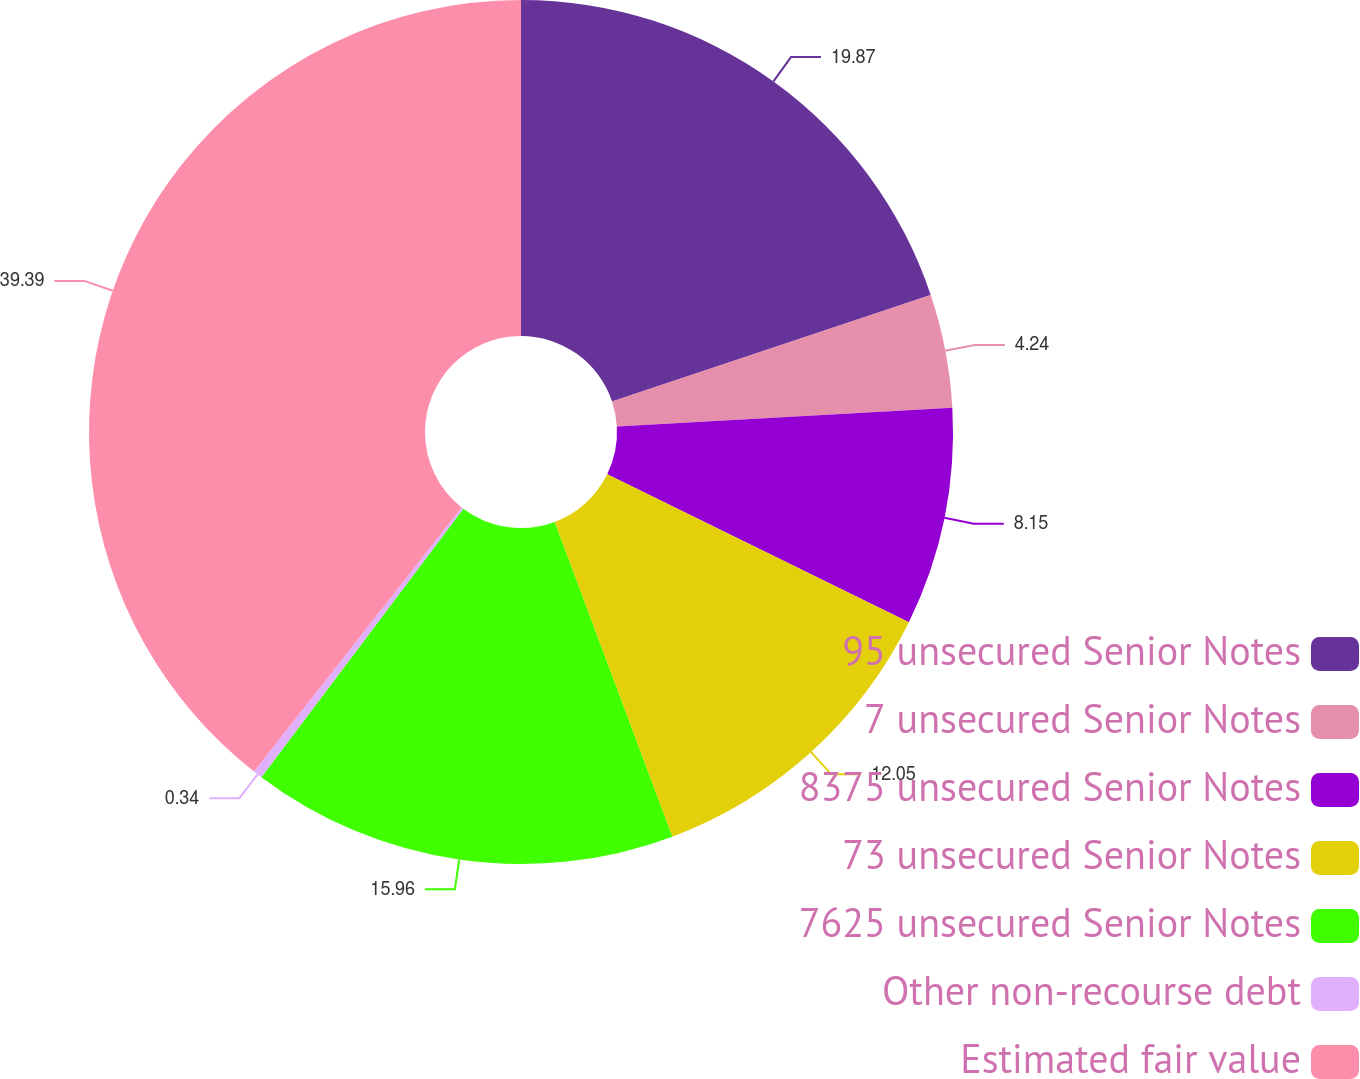Convert chart to OTSL. <chart><loc_0><loc_0><loc_500><loc_500><pie_chart><fcel>95 unsecured Senior Notes<fcel>7 unsecured Senior Notes<fcel>8375 unsecured Senior Notes<fcel>73 unsecured Senior Notes<fcel>7625 unsecured Senior Notes<fcel>Other non-recourse debt<fcel>Estimated fair value<nl><fcel>19.87%<fcel>4.24%<fcel>8.15%<fcel>12.05%<fcel>15.96%<fcel>0.34%<fcel>39.4%<nl></chart> 